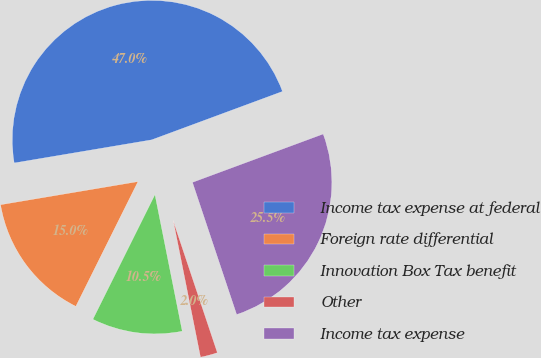<chart> <loc_0><loc_0><loc_500><loc_500><pie_chart><fcel>Income tax expense at federal<fcel>Foreign rate differential<fcel>Innovation Box Tax benefit<fcel>Other<fcel>Income tax expense<nl><fcel>47.01%<fcel>14.99%<fcel>10.49%<fcel>2.0%<fcel>25.5%<nl></chart> 